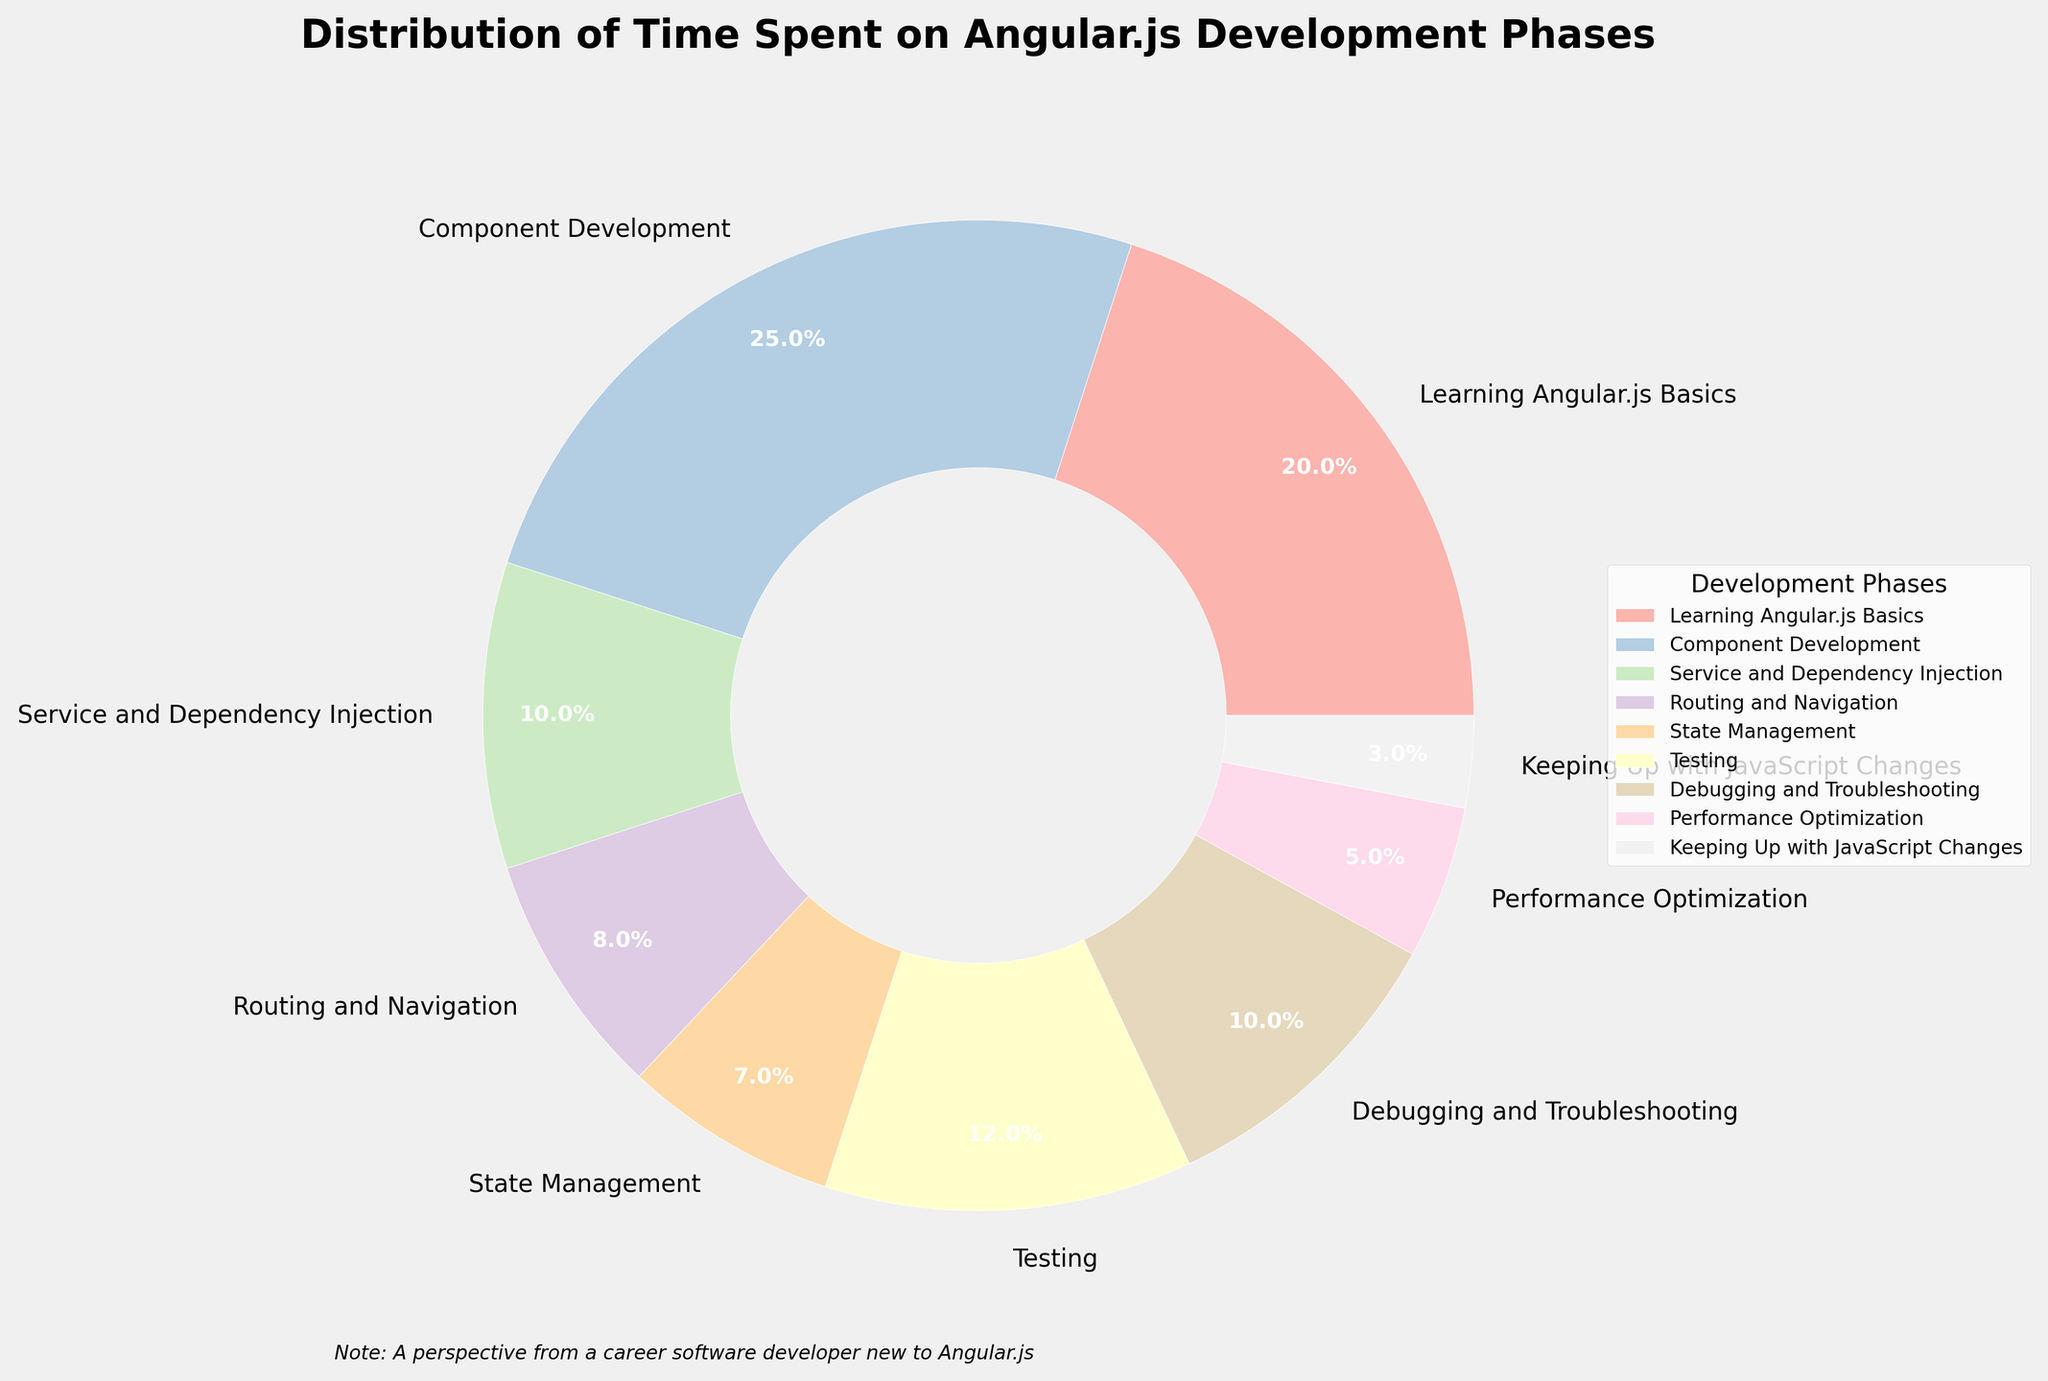What's the largest phase in terms of time spent? The largest phase is the one with the highest percentage in the pie chart. From the visual inspection, the "Component Development" phase occupies the largest portion with 25%.
Answer: Component Development What is the aggregate percentage of time spent on "Learning Angular.js Basics" and "Component Development"? Add the percentages of "Learning Angular.js Basics" (20%) and "Component Development" (25%). So, 20% + 25% = 45%.
Answer: 45% Which phase spends more time, "Testing" or "Debugging and Troubleshooting"? Compare the percentages of "Testing" (12%) and "Debugging and Troubleshooting" (10%). Since 12% > 10%, "Testing" spends more time.
Answer: Testing How much more percentage of time is spent on "Service and Dependency Injection" compared to "State Management"? Subtract the percentage of "State Management" (7%) from "Service and Dependency Injection" (10%). So, 10% - 7% = 3%.
Answer: 3% What is the combined time spent on "Routing and Navigation", "State Management", and "Performance Optimization"? Add the percentages of "Routing and Navigation" (8%), "State Management" (7%), and "Performance Optimization" (5%). So, 8% + 7% + 5% = 20%.
Answer: 20% Is the time spent on "Keeping Up with JavaScript Changes" higher or lower than "Performance Optimization"? Compare the percentages of "Keeping Up with JavaScript Changes" (3%) and "Performance Optimization" (5%). Since 3% < 5%, it's lower.
Answer: Lower What is the difference in percentage between the highest and lowest time spent phases? Identify the highest percentage ("Component Development" with 25%) and the lowest percentage ("Keeping Up with JavaScript Changes" with 3%) and then subtract them. So, 25% - 3% = 22%.
Answer: 22% Which phase ranks third in terms of time spent? The phases in descending order of their percentages are: "Component Development" (25%), "Learning Angular.js Basics" (20%), "Testing" (12%). Hence, "Testing" comes third.
Answer: Testing What visual attribute is shared among all the phases in the pie chart? Every section representing phases in the pie chart has a different color. Therefore, the common visual attribute they share is that each section is color-coded uniquely.
Answer: Each section is color-coded uniquely What's the total percentage covered by phases that take below 10% time each? Sum the percentages of phases below 10%: "Service and Dependency Injection" (10%), "Routing and Navigation" (8%), "State Management" (7%), "Debugging and Troubleshooting" (10%), "Performance Optimization" (5%), "Keeping Up with JavaScript Changes" (3%). So, 10% + 8% + 7% + 10% + 5% + 3% = 43%.
Answer: 43% 